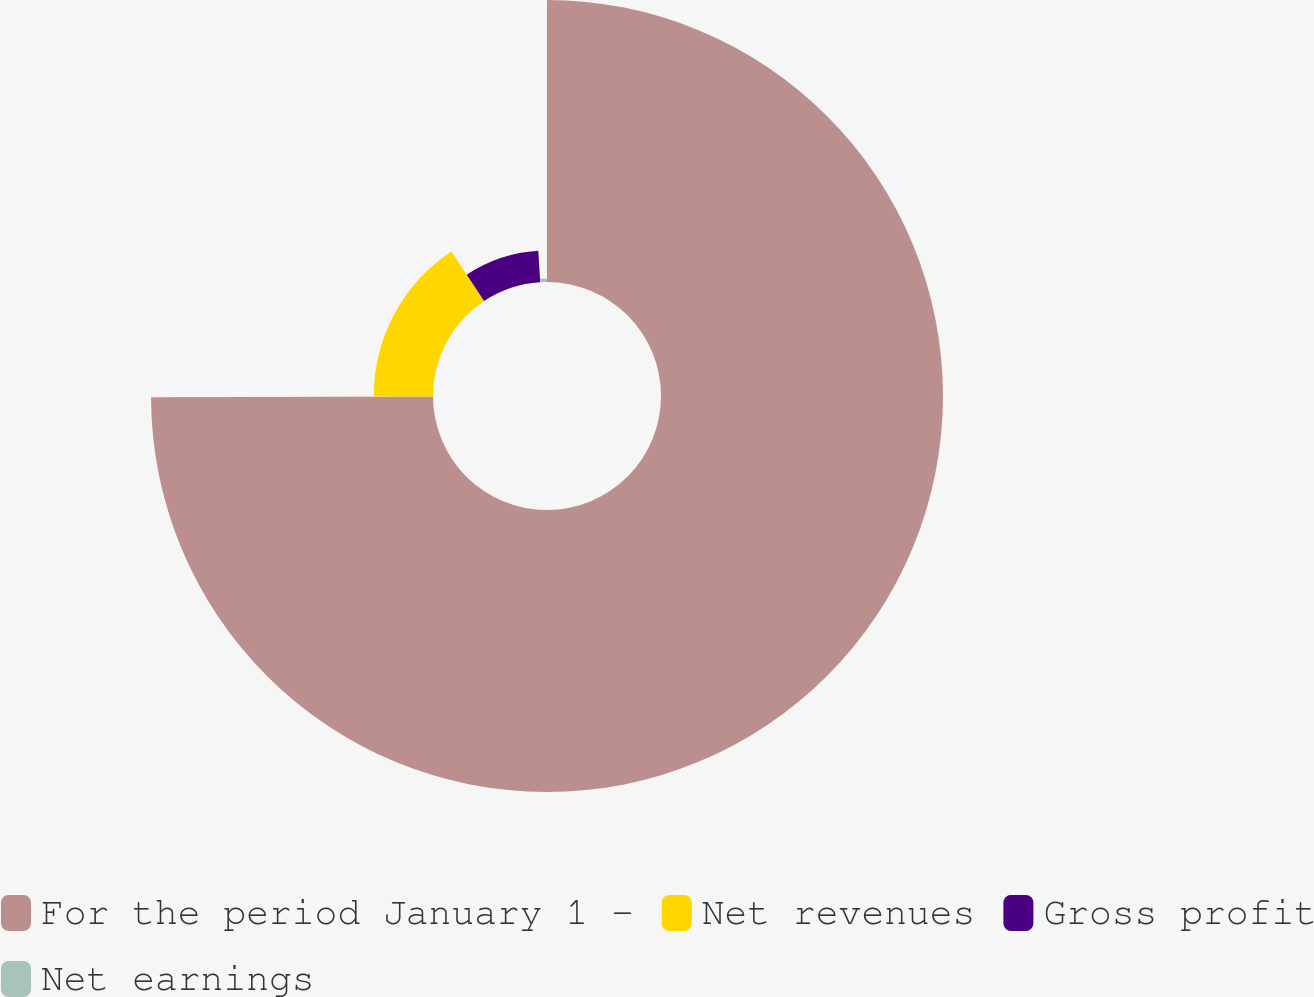<chart> <loc_0><loc_0><loc_500><loc_500><pie_chart><fcel>For the period January 1 -<fcel>Net revenues<fcel>Gross profit<fcel>Net earnings<nl><fcel>74.94%<fcel>15.75%<fcel>8.35%<fcel>0.95%<nl></chart> 